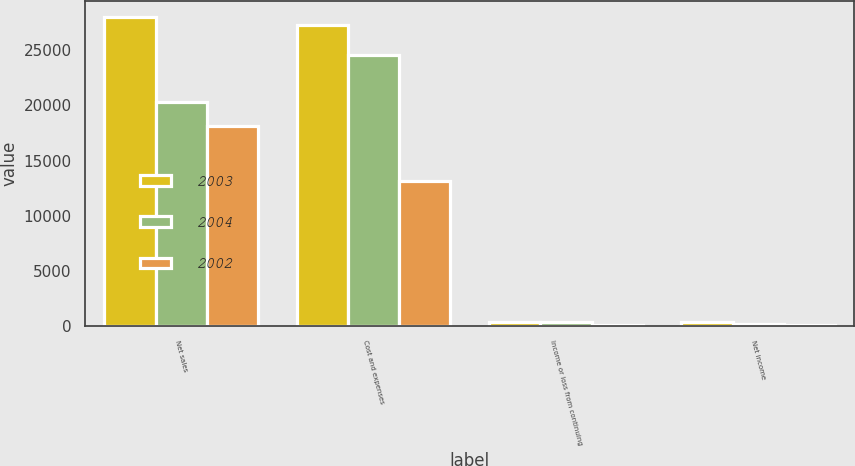Convert chart. <chart><loc_0><loc_0><loc_500><loc_500><stacked_bar_chart><ecel><fcel>Net sales<fcel>Cost and expenses<fcel>Income or loss from continuing<fcel>Net income<nl><fcel>2003<fcel>28015<fcel>27226<fcel>419<fcel>384<nl><fcel>2004<fcel>20281<fcel>24568<fcel>368<fcel>250<nl><fcel>2002<fcel>18146<fcel>13177<fcel>163<fcel>107<nl></chart> 